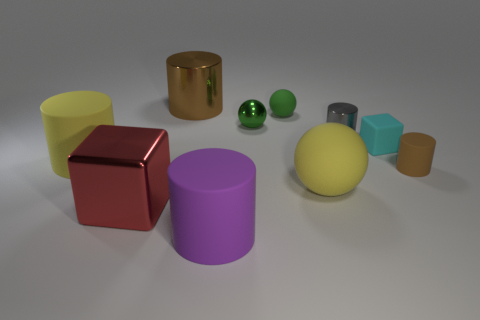Subtract 2 cylinders. How many cylinders are left? 3 Subtract all yellow cylinders. How many cylinders are left? 4 Subtract all tiny metal cylinders. How many cylinders are left? 4 Subtract all red cylinders. Subtract all blue cubes. How many cylinders are left? 5 Subtract all balls. How many objects are left? 7 Add 6 small purple rubber cylinders. How many small purple rubber cylinders exist? 6 Subtract 0 blue cylinders. How many objects are left? 10 Subtract all big cyan things. Subtract all large cylinders. How many objects are left? 7 Add 5 big yellow matte cylinders. How many big yellow matte cylinders are left? 6 